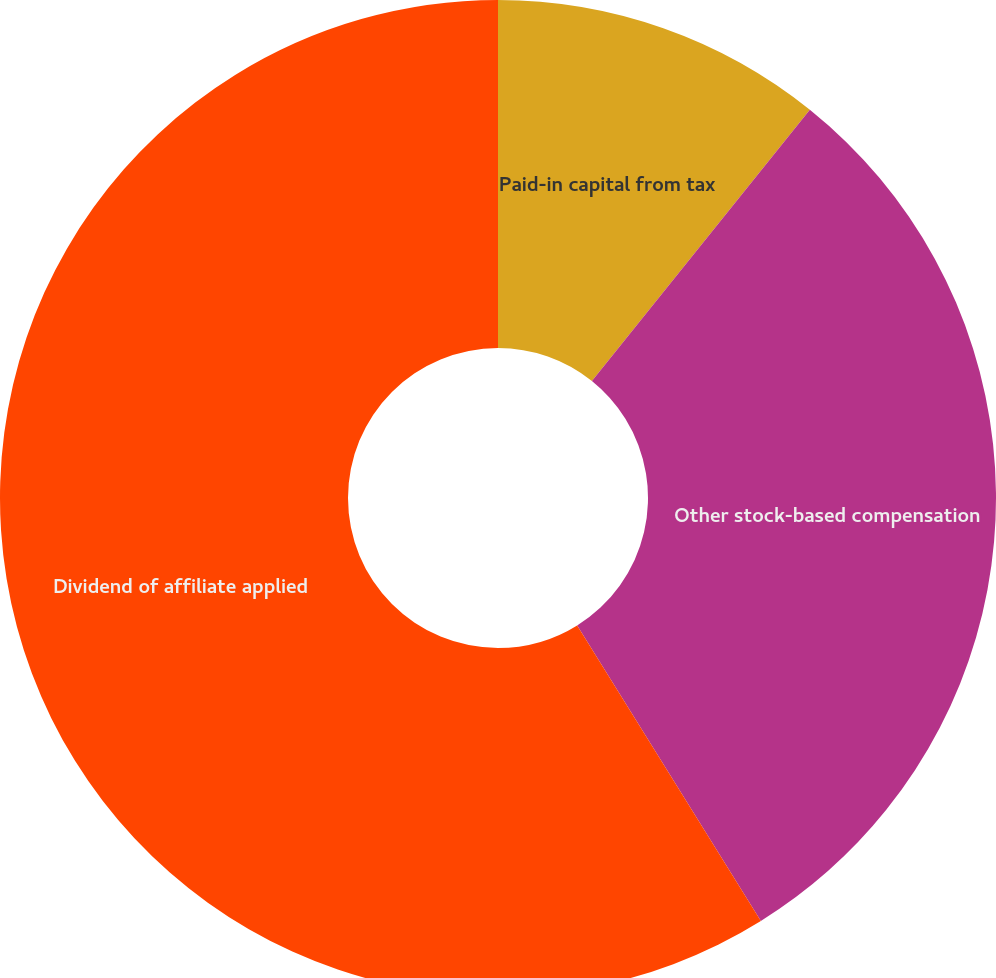<chart> <loc_0><loc_0><loc_500><loc_500><pie_chart><fcel>Paid-in capital from tax<fcel>Other stock-based compensation<fcel>Dividend of affiliate applied<nl><fcel>10.77%<fcel>30.38%<fcel>58.85%<nl></chart> 